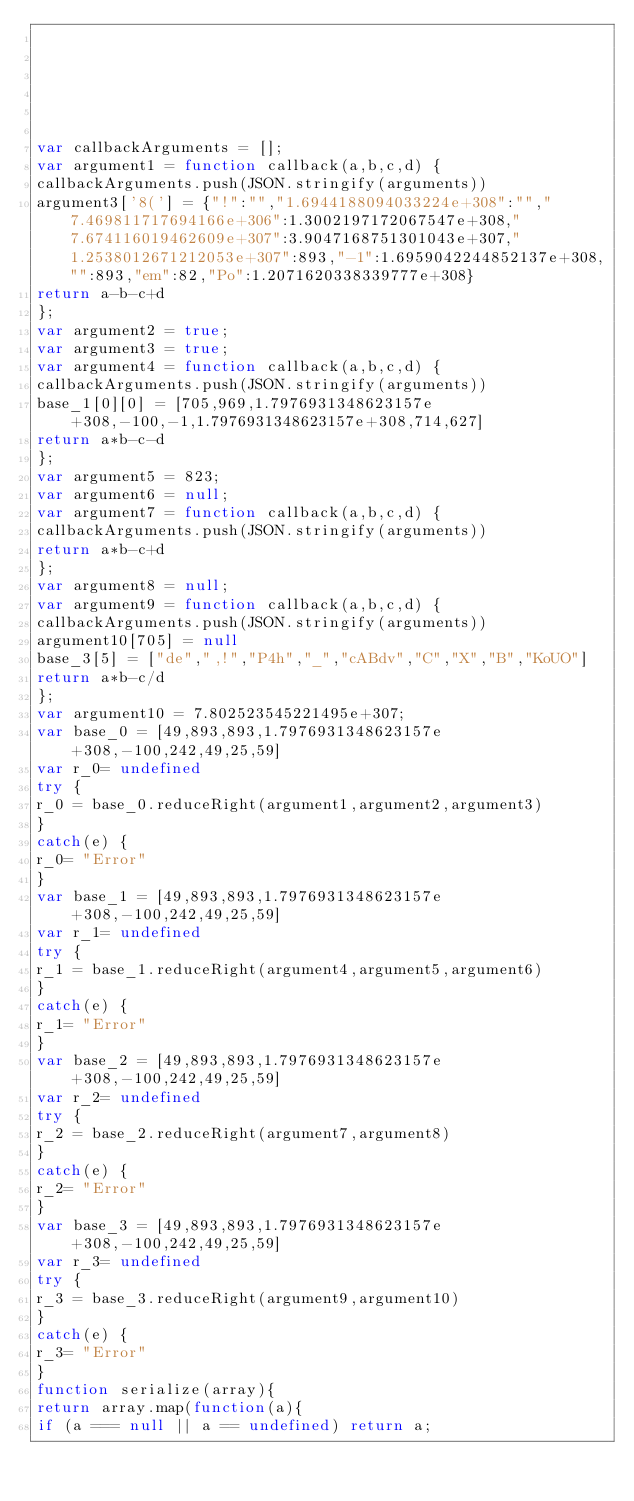<code> <loc_0><loc_0><loc_500><loc_500><_JavaScript_>





var callbackArguments = [];
var argument1 = function callback(a,b,c,d) { 
callbackArguments.push(JSON.stringify(arguments))
argument3['8('] = {"!":"","1.6944188094033224e+308":"","7.469811717694166e+306":1.3002197172067547e+308,"7.674116019462609e+307":3.9047168751301043e+307,"1.2538012671212053e+307":893,"-1":1.6959042244852137e+308,"":893,"em":82,"Po":1.2071620338339777e+308}
return a-b-c+d
};
var argument2 = true;
var argument3 = true;
var argument4 = function callback(a,b,c,d) { 
callbackArguments.push(JSON.stringify(arguments))
base_1[0][0] = [705,969,1.7976931348623157e+308,-100,-1,1.7976931348623157e+308,714,627]
return a*b-c-d
};
var argument5 = 823;
var argument6 = null;
var argument7 = function callback(a,b,c,d) { 
callbackArguments.push(JSON.stringify(arguments))
return a*b-c+d
};
var argument8 = null;
var argument9 = function callback(a,b,c,d) { 
callbackArguments.push(JSON.stringify(arguments))
argument10[705] = null
base_3[5] = ["de",",!","P4h","_","cABdv","C","X","B","KoUO"]
return a*b-c/d
};
var argument10 = 7.802523545221495e+307;
var base_0 = [49,893,893,1.7976931348623157e+308,-100,242,49,25,59]
var r_0= undefined
try {
r_0 = base_0.reduceRight(argument1,argument2,argument3)
}
catch(e) {
r_0= "Error"
}
var base_1 = [49,893,893,1.7976931348623157e+308,-100,242,49,25,59]
var r_1= undefined
try {
r_1 = base_1.reduceRight(argument4,argument5,argument6)
}
catch(e) {
r_1= "Error"
}
var base_2 = [49,893,893,1.7976931348623157e+308,-100,242,49,25,59]
var r_2= undefined
try {
r_2 = base_2.reduceRight(argument7,argument8)
}
catch(e) {
r_2= "Error"
}
var base_3 = [49,893,893,1.7976931348623157e+308,-100,242,49,25,59]
var r_3= undefined
try {
r_3 = base_3.reduceRight(argument9,argument10)
}
catch(e) {
r_3= "Error"
}
function serialize(array){
return array.map(function(a){
if (a === null || a == undefined) return a;</code> 